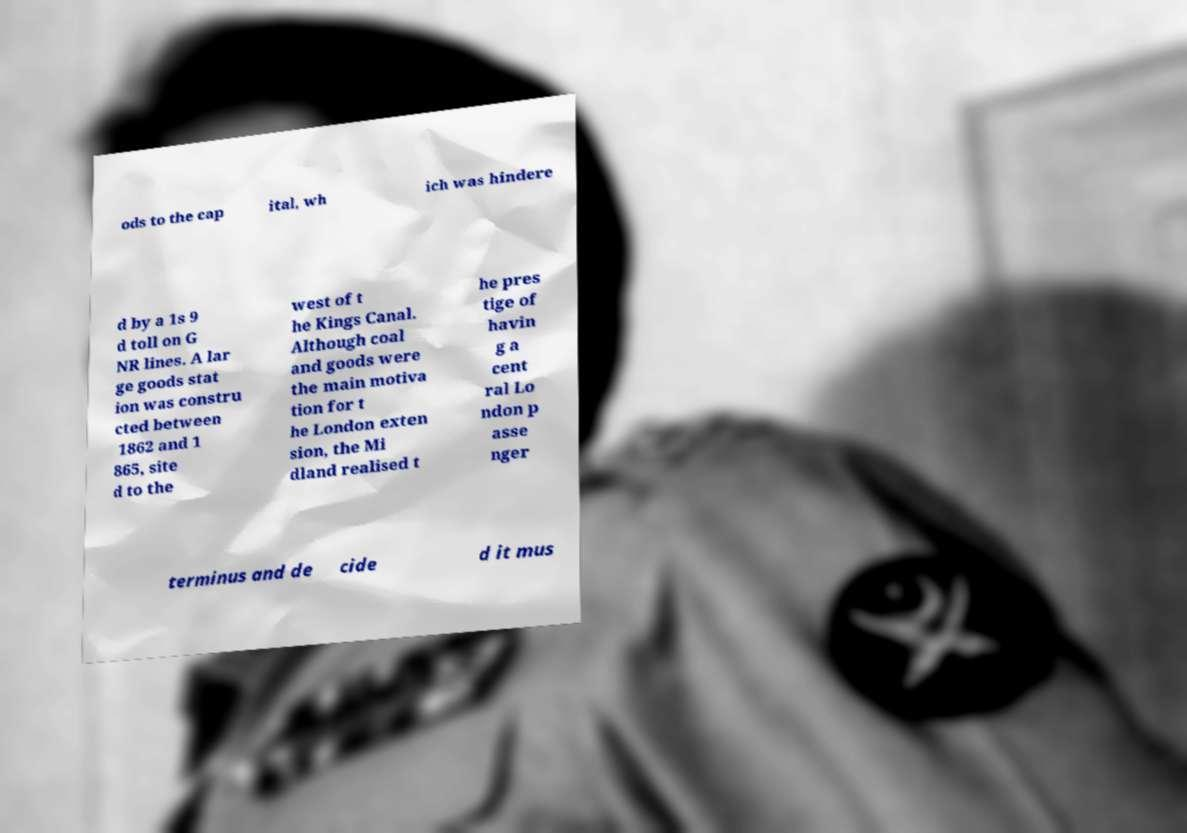Could you assist in decoding the text presented in this image and type it out clearly? ods to the cap ital, wh ich was hindere d by a 1s 9 d toll on G NR lines. A lar ge goods stat ion was constru cted between 1862 and 1 865, site d to the west of t he Kings Canal. Although coal and goods were the main motiva tion for t he London exten sion, the Mi dland realised t he pres tige of havin g a cent ral Lo ndon p asse nger terminus and de cide d it mus 